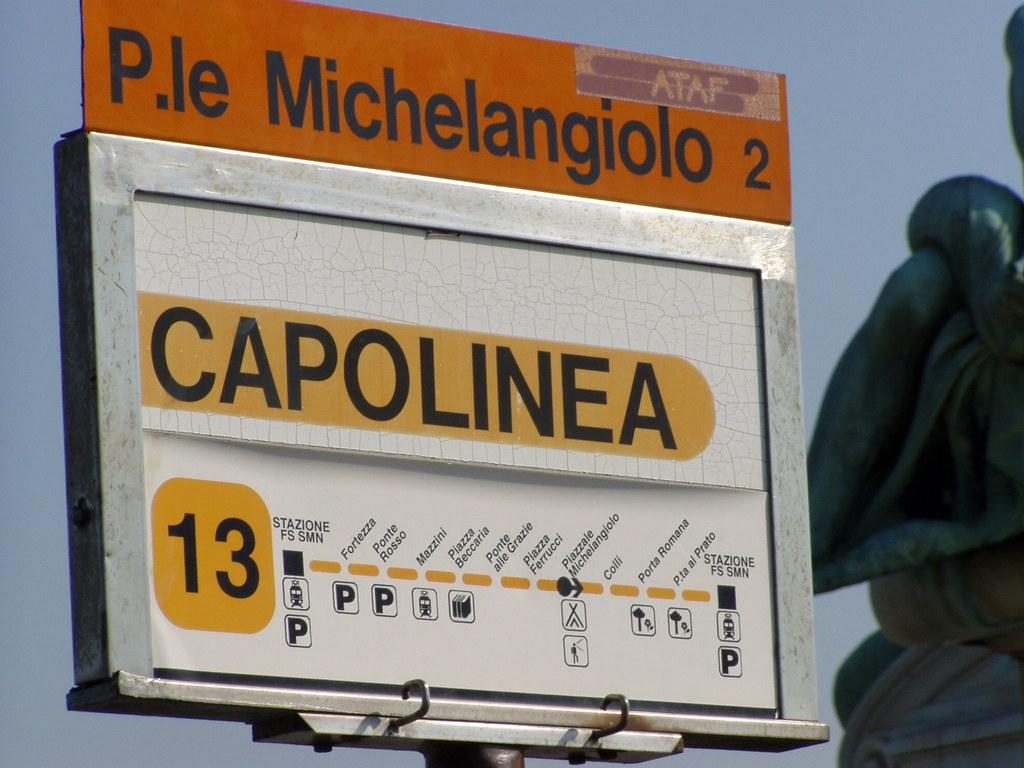<image>
Offer a succinct explanation of the picture presented. A map of transportation options and parking for P.le Michelangiolo. 